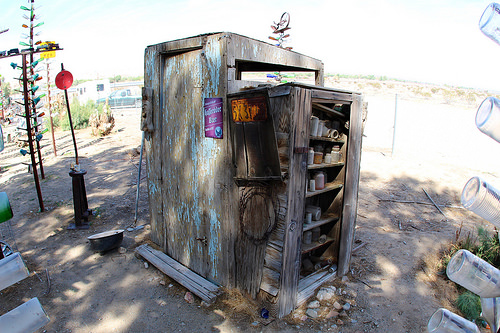<image>
Is there a bottles in front of the shelf? Yes. The bottles is positioned in front of the shelf, appearing closer to the camera viewpoint. 